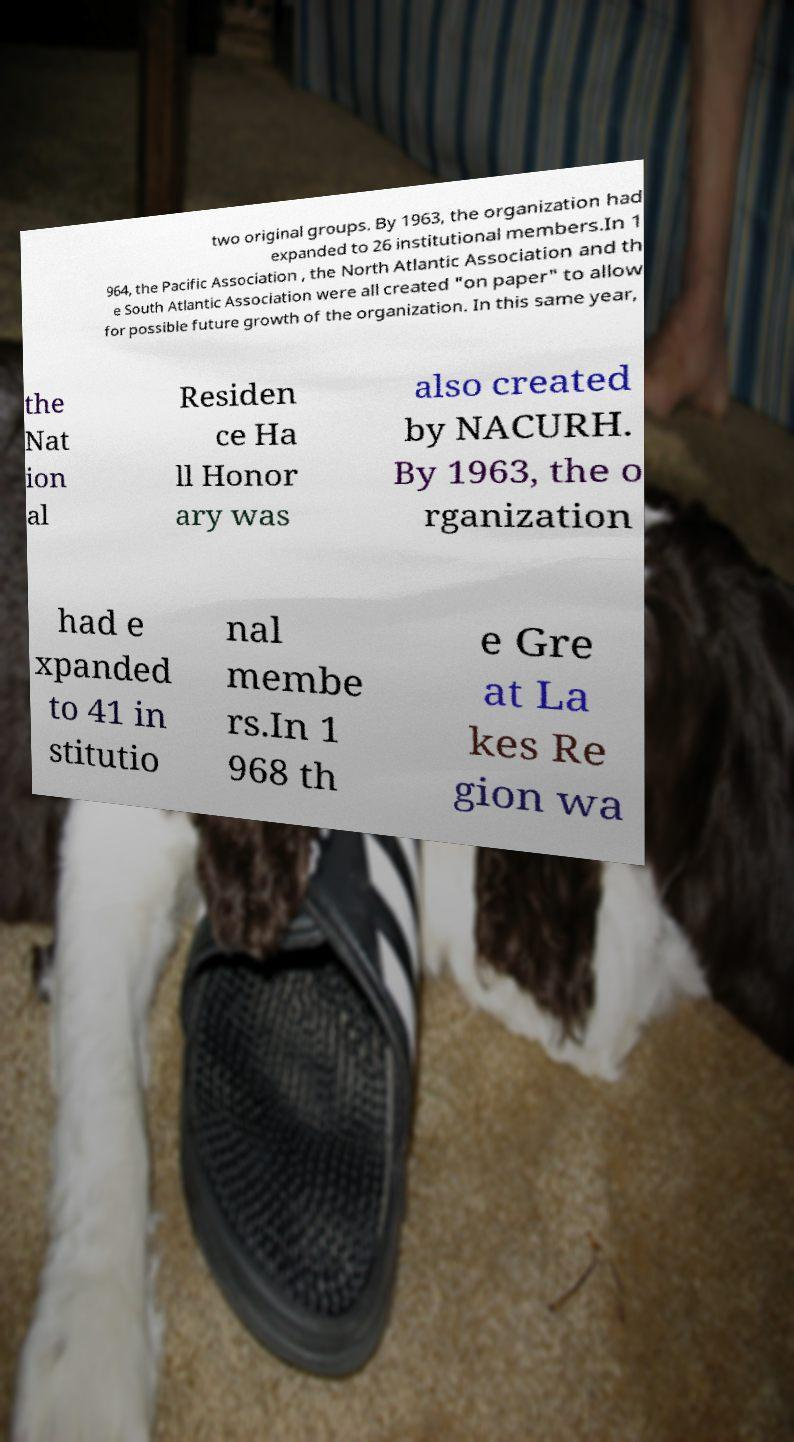What messages or text are displayed in this image? I need them in a readable, typed format. two original groups. By 1963, the organization had expanded to 26 institutional members.In 1 964, the Pacific Association , the North Atlantic Association and th e South Atlantic Association were all created "on paper" to allow for possible future growth of the organization. In this same year, the Nat ion al Residen ce Ha ll Honor ary was also created by NACURH. By 1963, the o rganization had e xpanded to 41 in stitutio nal membe rs.In 1 968 th e Gre at La kes Re gion wa 